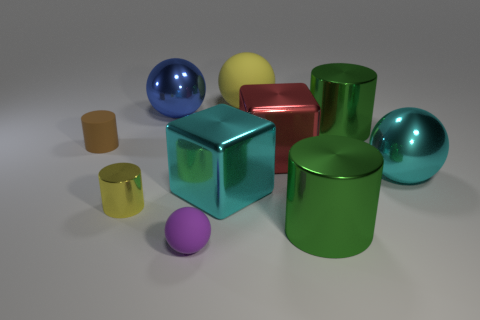There is a small rubber thing behind the tiny purple matte object; are there any red metal things on the left side of it?
Offer a very short reply. No. What shape is the yellow object to the right of the rubber ball that is in front of the blue shiny thing?
Your answer should be compact. Sphere. Is the number of tiny red rubber cubes less than the number of metal balls?
Ensure brevity in your answer.  Yes. Is the tiny brown cylinder made of the same material as the cyan ball?
Offer a terse response. No. There is a thing that is both right of the large red metallic thing and in front of the yellow cylinder; what is its color?
Offer a terse response. Green. Are there any purple metallic cylinders that have the same size as the cyan block?
Ensure brevity in your answer.  No. There is a green cylinder to the left of the green metallic cylinder behind the yellow cylinder; how big is it?
Provide a succinct answer. Large. Are there fewer cyan metallic things that are left of the blue metallic thing than small yellow things?
Offer a terse response. Yes. Is the color of the small ball the same as the small shiny cylinder?
Offer a terse response. No. What is the size of the brown cylinder?
Give a very brief answer. Small. 